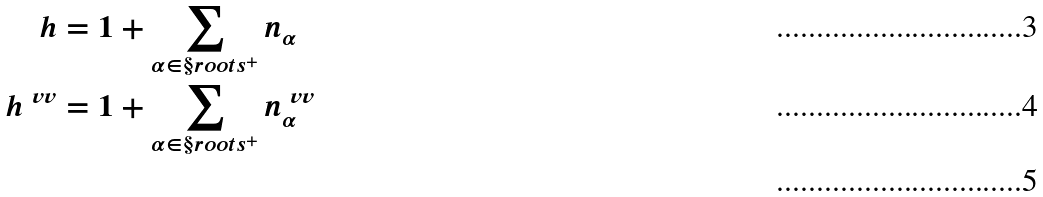<formula> <loc_0><loc_0><loc_500><loc_500>h & = 1 + \sum _ { \alpha \in \S r o o t s ^ { + } } n _ { \alpha } \\ h ^ { \ v v } & = 1 + \sum _ { \alpha \in \S r o o t s ^ { + } } n ^ { \ v v } _ { \alpha } \\</formula> 